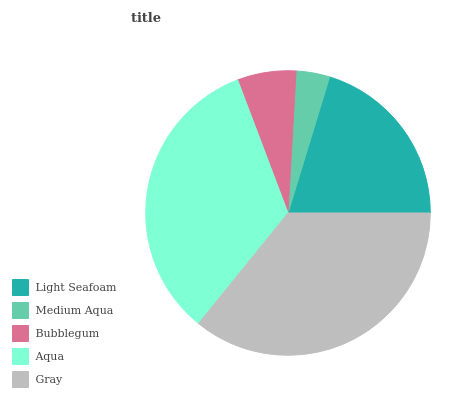Is Medium Aqua the minimum?
Answer yes or no. Yes. Is Gray the maximum?
Answer yes or no. Yes. Is Bubblegum the minimum?
Answer yes or no. No. Is Bubblegum the maximum?
Answer yes or no. No. Is Bubblegum greater than Medium Aqua?
Answer yes or no. Yes. Is Medium Aqua less than Bubblegum?
Answer yes or no. Yes. Is Medium Aqua greater than Bubblegum?
Answer yes or no. No. Is Bubblegum less than Medium Aqua?
Answer yes or no. No. Is Light Seafoam the high median?
Answer yes or no. Yes. Is Light Seafoam the low median?
Answer yes or no. Yes. Is Aqua the high median?
Answer yes or no. No. Is Aqua the low median?
Answer yes or no. No. 